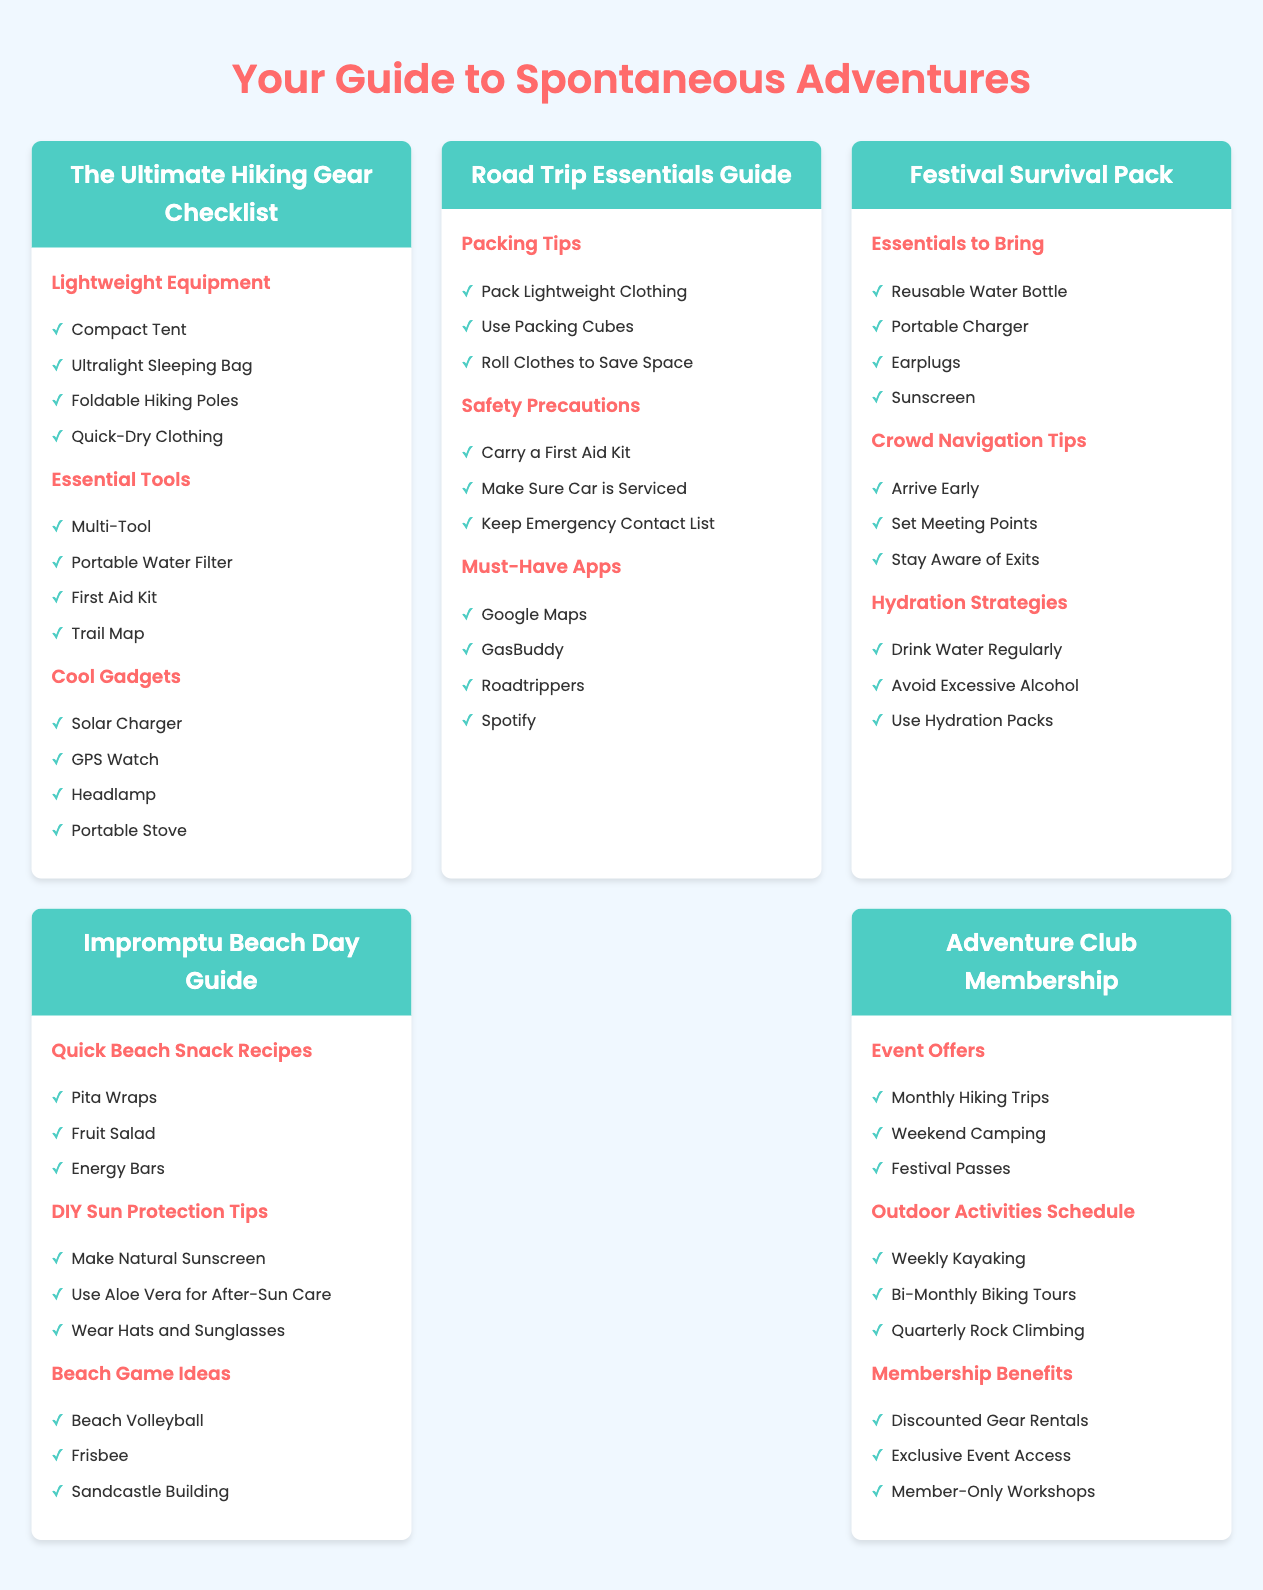What are the lightweight equipment items listed? The document provides a list of lightweight equipment items in the hiking gear checklist section.
Answer: Compact Tent, Ultralight Sleeping Bag, Foldable Hiking Poles, Quick-Dry Clothing Which must-have app for road trips is mentioned? The document lists specific apps in the road trip essentials guide section that are recommended for road trips.
Answer: Google Maps What essential tool is included in the hiking gear checklist? The document emphasizes important tools necessary for hiking and includes them under the essential tools section.
Answer: Multi-Tool How many hydration strategies are suggested in the festival survival pack section? The document outlines hydration strategies in the festival survival pack and presents them in a list format.
Answer: Three What is one of the beach game ideas listed? The document details beach game ideas in the impromptu beach day guide section, which includes recreational activities.
Answer: Beach Volleyball What event offer is included in the adventure club membership? The document specifies various offers related to the adventure club membership under the event offers section.
Answer: Monthly Hiking Trips What type of clothing packing tip is provided for road trips? The document includes packing tips tailored for road trips that focus on efficient packing strategies.
Answer: Pack Lightweight Clothing Which DIY sun protection tip is mentioned? The document lists DIY sun protection tips in the impromptu beach day guide section that can be utilized for sun safety.
Answer: Make Natural Sunscreen 